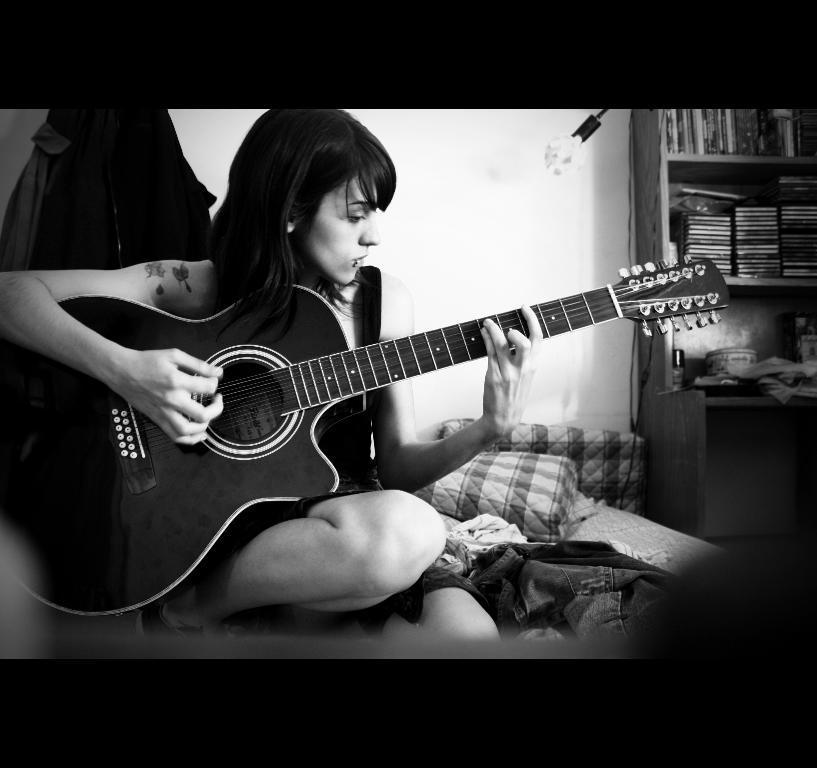How would you summarize this image in a sentence or two? This is a black and white image. We can see a lady playing a musical instrument. We can see some clothes. We can see the shelves with objects in it. We can see the wall. 